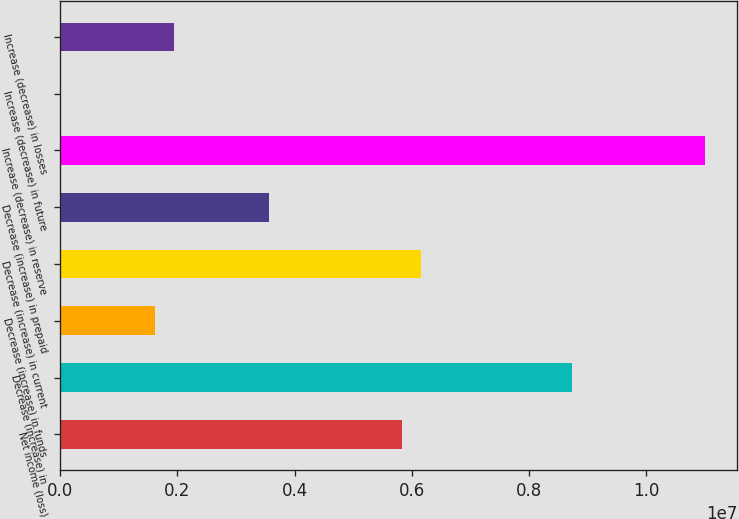Convert chart. <chart><loc_0><loc_0><loc_500><loc_500><bar_chart><fcel>Net income (loss)<fcel>Decrease (increase) in<fcel>Decrease (increase) in funds<fcel>Decrease (increase) in current<fcel>Decrease (increase) in prepaid<fcel>Increase (decrease) in reserve<fcel>Increase (decrease) in future<fcel>Increase (decrease) in losses<nl><fcel>5.82526e+06<fcel>8.73579e+06<fcel>1.62115e+06<fcel>6.14865e+06<fcel>3.56151e+06<fcel>1.09995e+07<fcel>4185<fcel>1.94454e+06<nl></chart> 